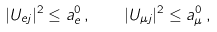<formula> <loc_0><loc_0><loc_500><loc_500>| U _ { { e } j } | ^ { 2 } \leq a _ { e } ^ { 0 } \, , \quad | U _ { { \mu } j } | ^ { 2 } \leq a _ { \mu } ^ { 0 } \, ,</formula> 